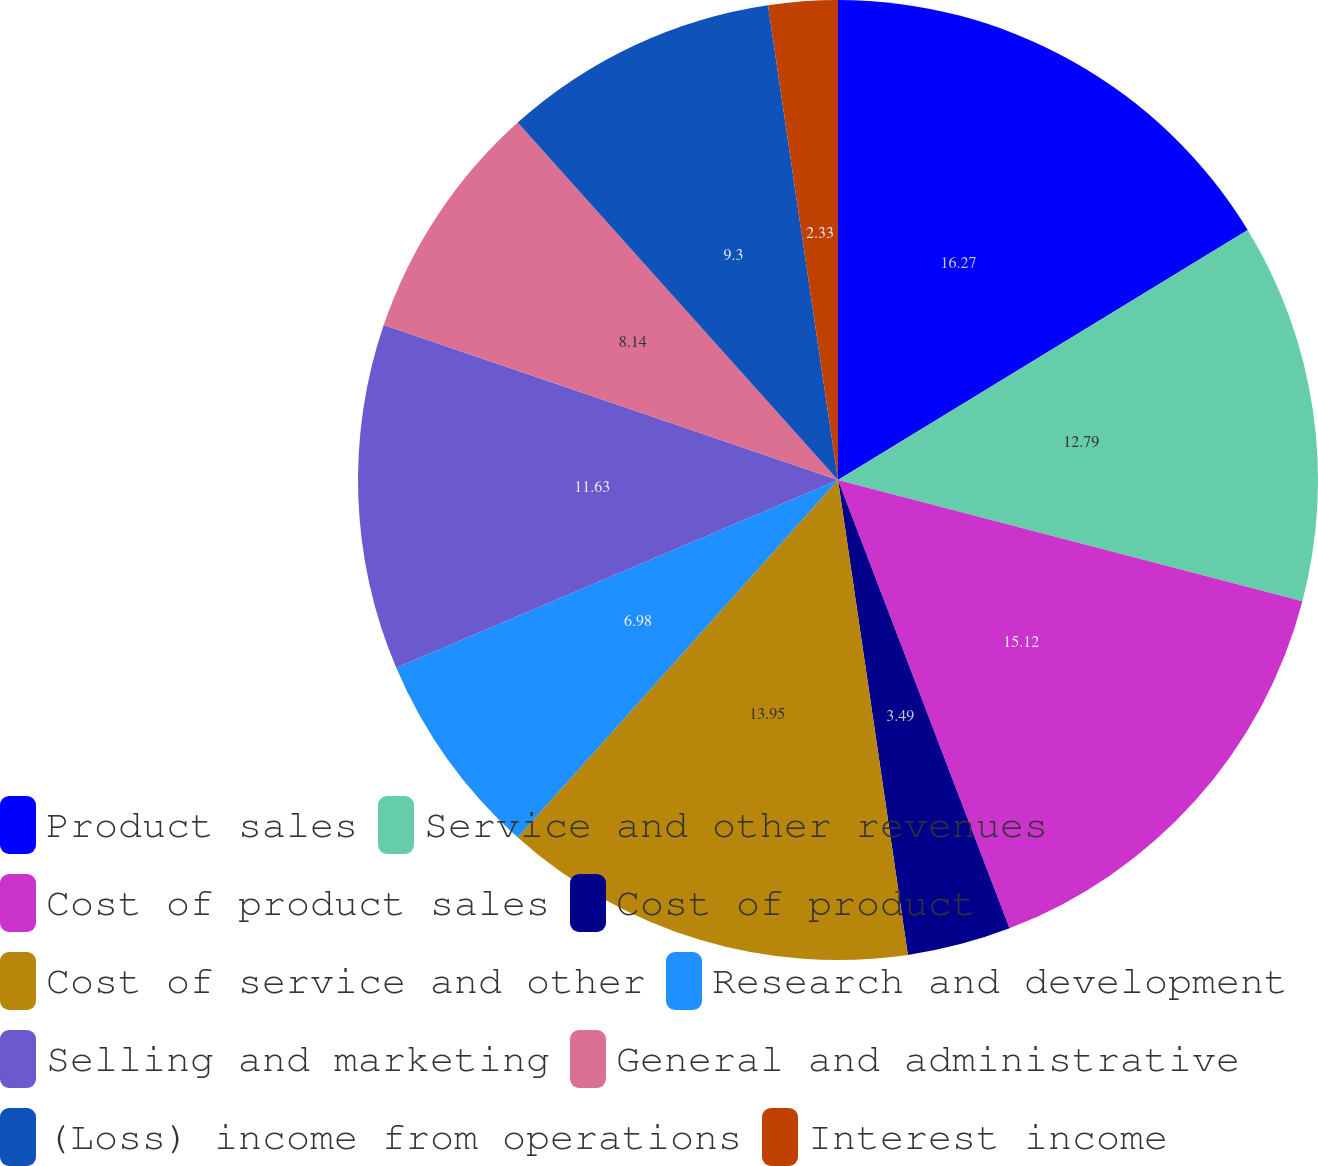Convert chart. <chart><loc_0><loc_0><loc_500><loc_500><pie_chart><fcel>Product sales<fcel>Service and other revenues<fcel>Cost of product sales<fcel>Cost of product<fcel>Cost of service and other<fcel>Research and development<fcel>Selling and marketing<fcel>General and administrative<fcel>(Loss) income from operations<fcel>Interest income<nl><fcel>16.28%<fcel>12.79%<fcel>15.12%<fcel>3.49%<fcel>13.95%<fcel>6.98%<fcel>11.63%<fcel>8.14%<fcel>9.3%<fcel>2.33%<nl></chart> 